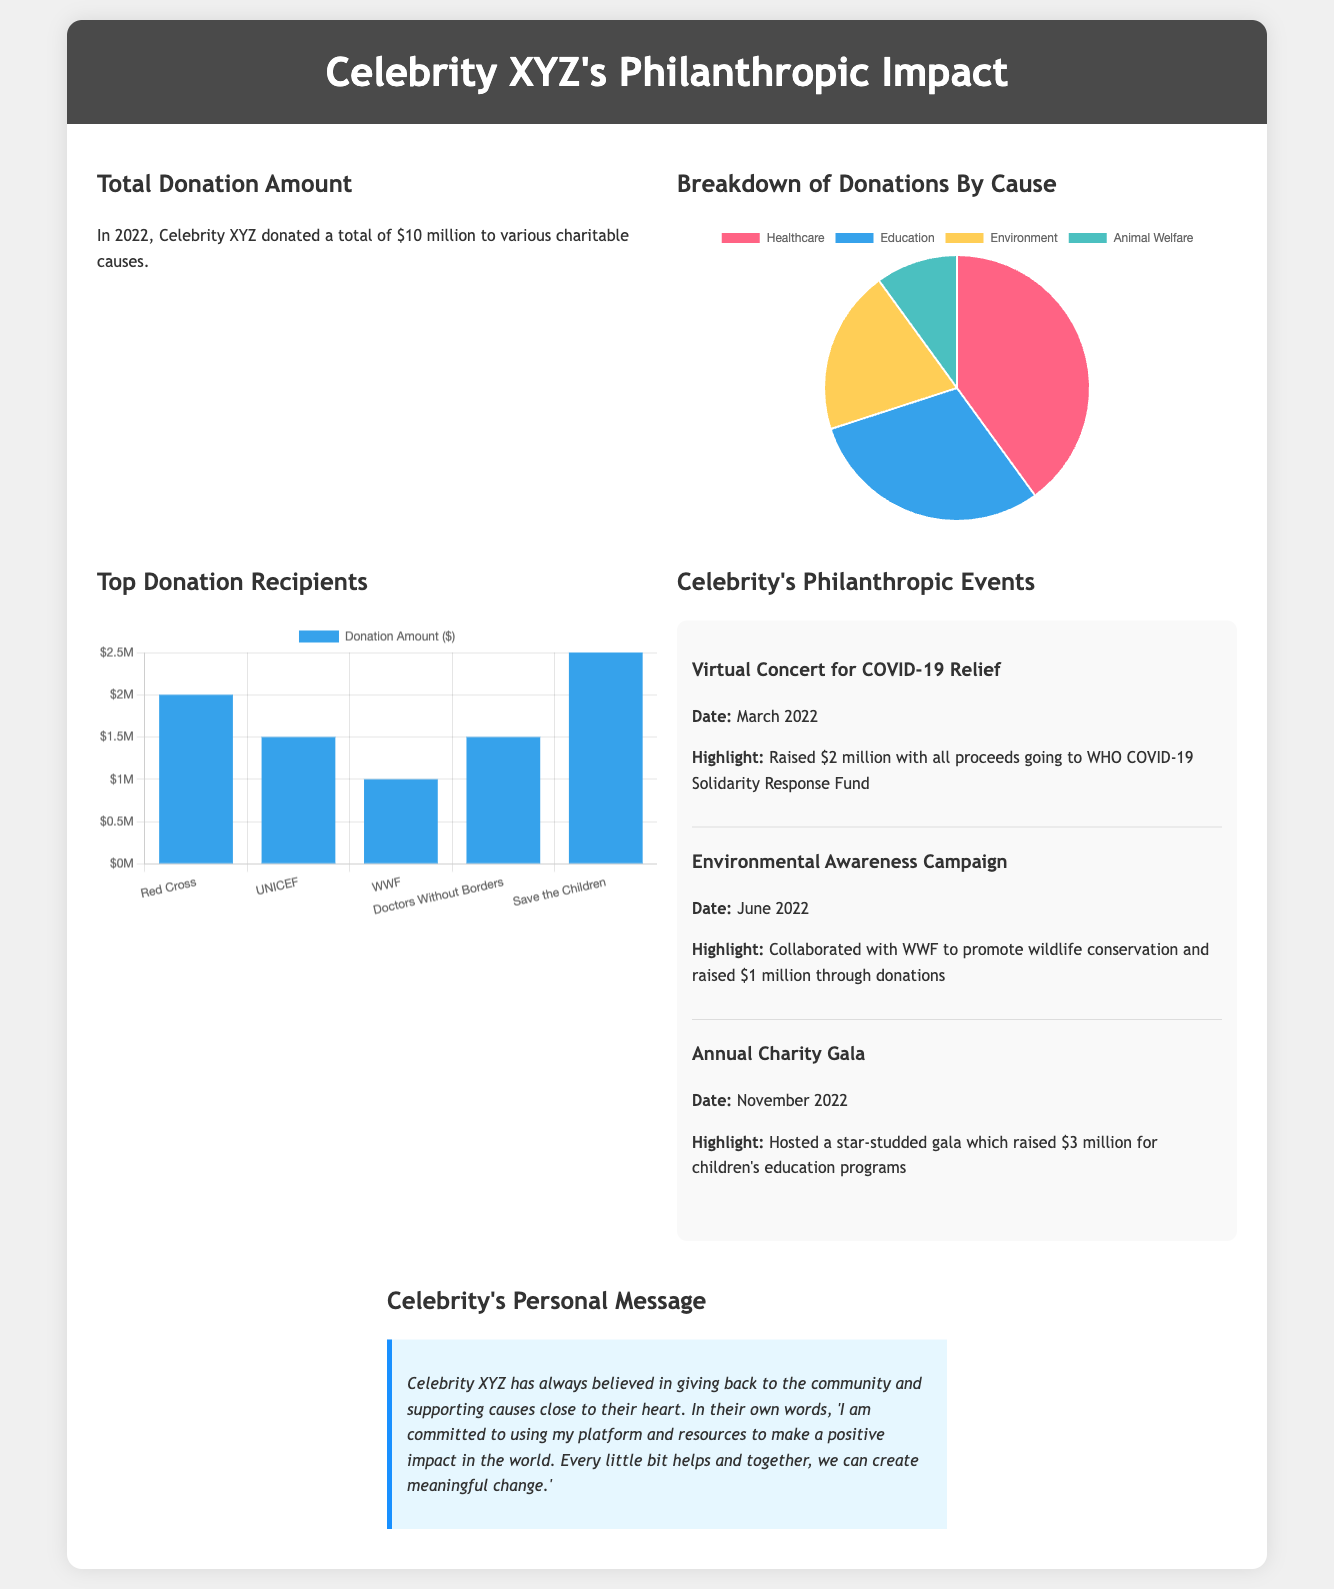What was the total donation amount? The total donation amount is stated in the document as $10 million.
Answer: $10 million What percentage of donations went to Healthcare? The document shows that $4 million was donated to Healthcare, which is the largest portion of the total donation.
Answer: $4 million Which event raised the most money? The Annual Charity Gala raised $3 million, making it the event with the highest amount raised.
Answer: Annual Charity Gala How much was raised in the Virtual Concert for COVID-19 Relief? The highlight mentions that $2 million was raised during this specific event.
Answer: $2 million What organization received the highest donation? The document indicates that Save the Children received the highest amount at $2.5 million.
Answer: Save the Children How many causes are listed in the Breakdown of Donations By Cause chart? The chart includes four different causes as indicated in the document.
Answer: Four What was the date of the Environmental Awareness Campaign? The document states that this campaign took place in June 2022.
Answer: June 2022 What is the overall theme of Celebrity XYZ’s personal message? The overall theme emphasizes commitment to making a positive impact in the world.
Answer: Positive impact Which cause received the least amount of donations? The document shows that Animal Welfare received the least donations at $1 million.
Answer: Animal Welfare 